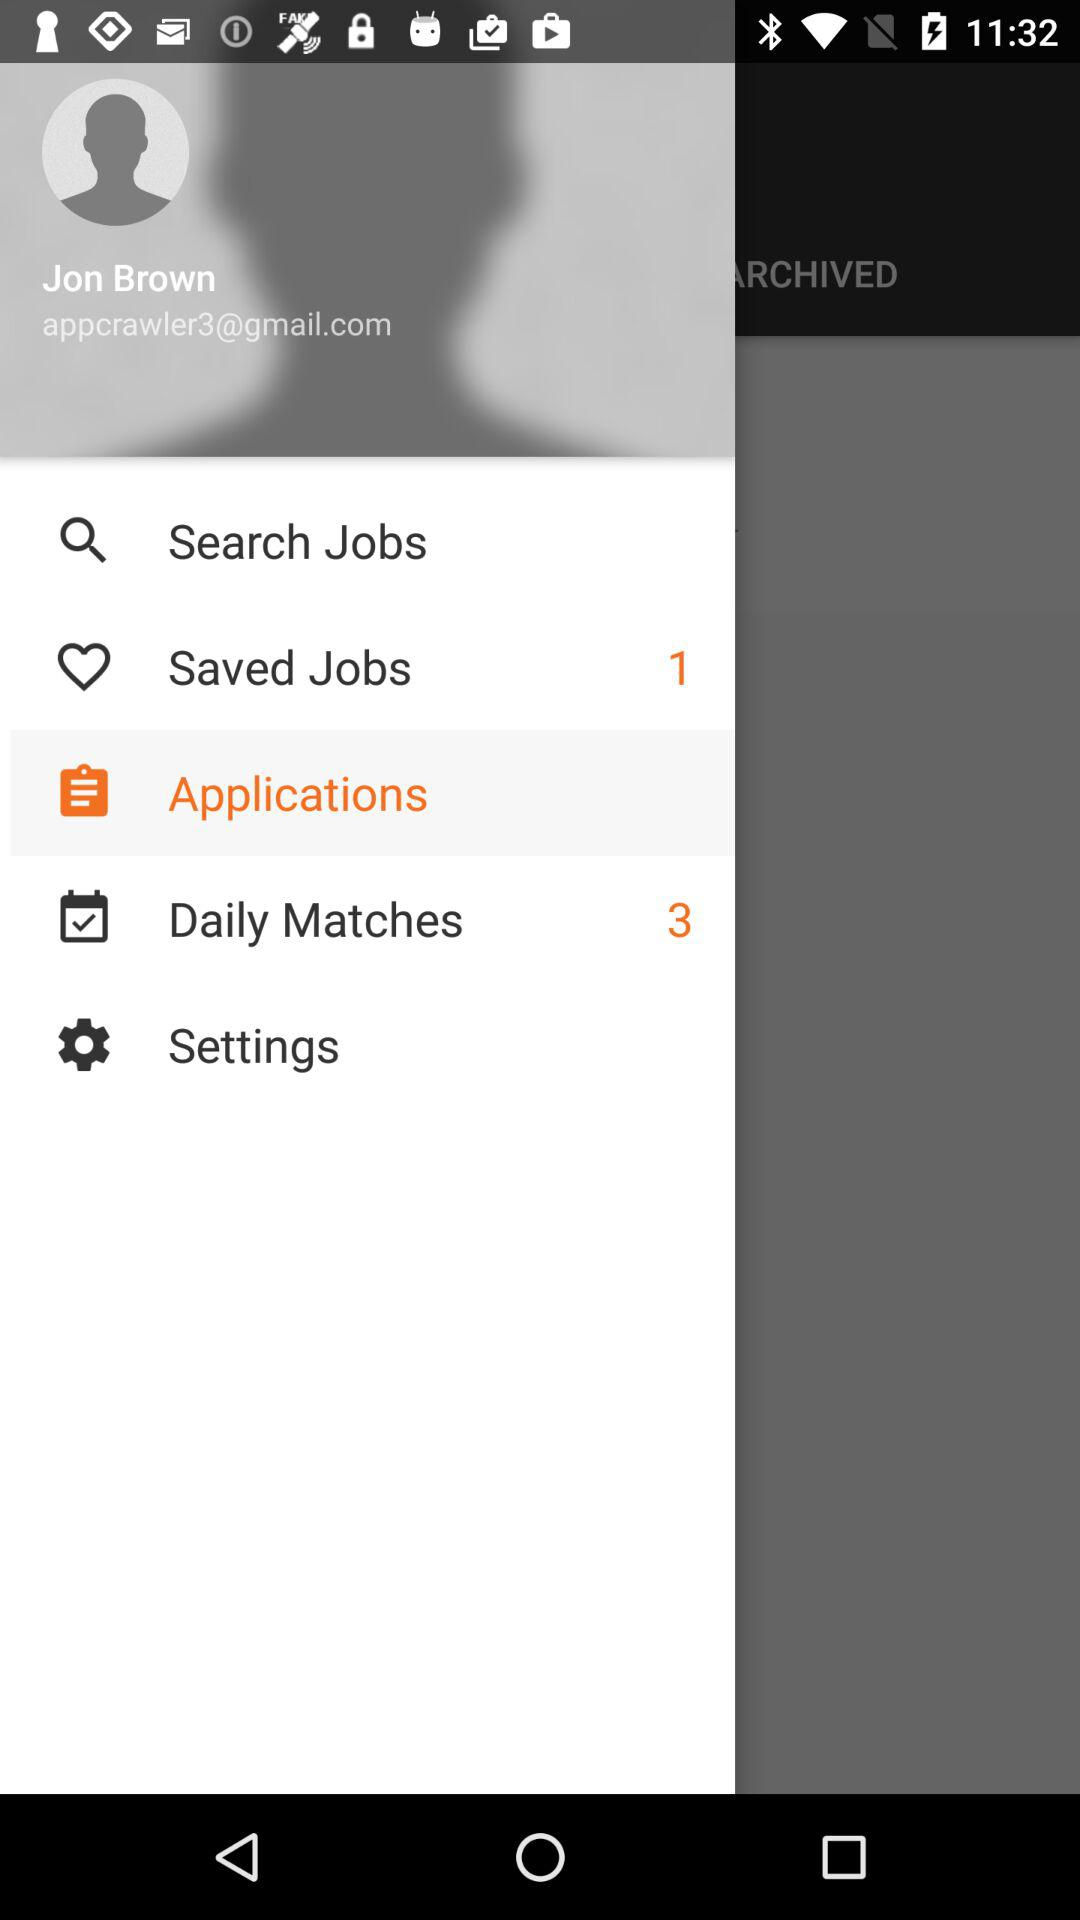What is the login name? The login name is "Jon Brown". 